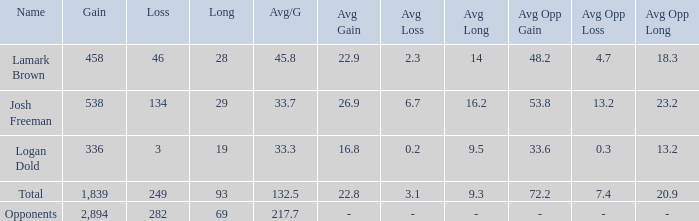Which avg/g holds an improvement of 1,839? 132.5. 